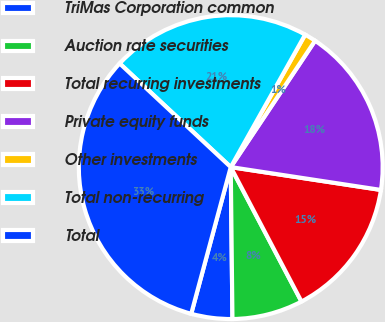<chart> <loc_0><loc_0><loc_500><loc_500><pie_chart><fcel>TriMas Corporation common<fcel>Auction rate securities<fcel>Total recurring investments<fcel>Private equity funds<fcel>Other investments<fcel>Total non-recurring<fcel>Total<nl><fcel>4.37%<fcel>7.53%<fcel>14.89%<fcel>18.04%<fcel>1.22%<fcel>21.2%<fcel>32.76%<nl></chart> 